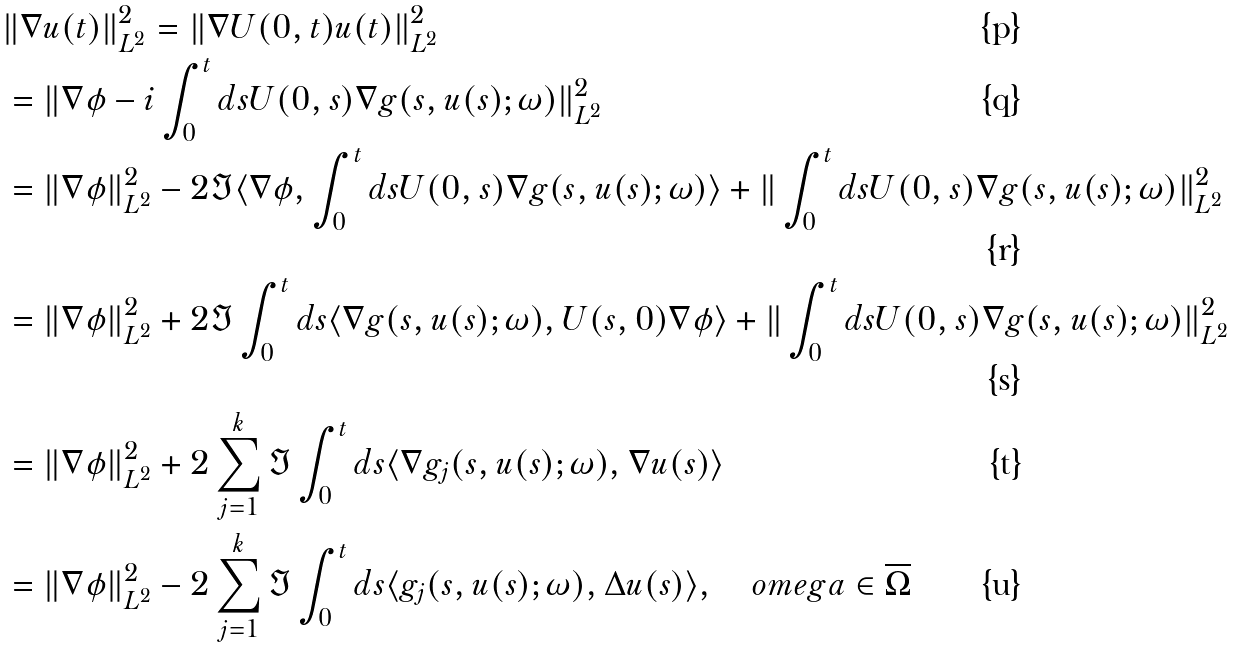Convert formula to latex. <formula><loc_0><loc_0><loc_500><loc_500>& \| \nabla u ( t ) \| ^ { 2 } _ { L ^ { 2 } } = \| \nabla U ( 0 , t ) u ( t ) \| ^ { 2 } _ { L ^ { 2 } } \\ & = \| \nabla \phi - i \int _ { 0 } ^ { t } d s U ( 0 , s ) \nabla g ( s , u ( s ) ; \omega ) \| ^ { 2 } _ { L ^ { 2 } } \\ & = \| \nabla \phi \| _ { L ^ { 2 } } ^ { 2 } - 2 \Im \langle \nabla \phi , \int _ { 0 } ^ { t } d s U ( 0 , s ) \nabla g ( s , u ( s ) ; \omega ) \rangle + \| \int _ { 0 } ^ { t } d s U ( 0 , s ) \nabla g ( s , u ( s ) ; \omega ) \| _ { L ^ { 2 } } ^ { 2 } \\ & = \| \nabla \phi \| _ { L ^ { 2 } } ^ { 2 } + 2 \Im \int _ { 0 } ^ { t } d s \langle \nabla g ( s , u ( s ) ; \omega ) , U ( s , 0 ) \nabla \phi \rangle + \| \int _ { 0 } ^ { t } d s U ( 0 , s ) \nabla g ( s , u ( s ) ; \omega ) \| _ { L ^ { 2 } } ^ { 2 } \\ & = \| \nabla \phi \| _ { L ^ { 2 } } ^ { 2 } + 2 \sum _ { j = 1 } ^ { k } \Im \int _ { 0 } ^ { t } d s \langle \nabla g _ { j } ( s , u ( s ) ; \omega ) , \nabla u ( s ) \rangle \\ & = \| \nabla \phi \| _ { L ^ { 2 } } ^ { 2 } - 2 \sum _ { j = 1 } ^ { k } \Im \int _ { 0 } ^ { t } d s \langle g _ { j } ( s , u ( s ) ; \omega ) , \Delta u ( s ) \rangle , \quad o m e g a \in \overline { \Omega }</formula> 